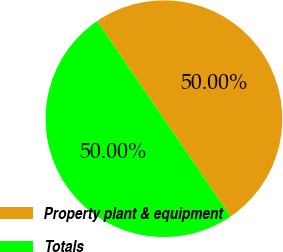Convert chart to OTSL. <chart><loc_0><loc_0><loc_500><loc_500><pie_chart><fcel>Property plant & equipment<fcel>Totals<nl><fcel>50.0%<fcel>50.0%<nl></chart> 